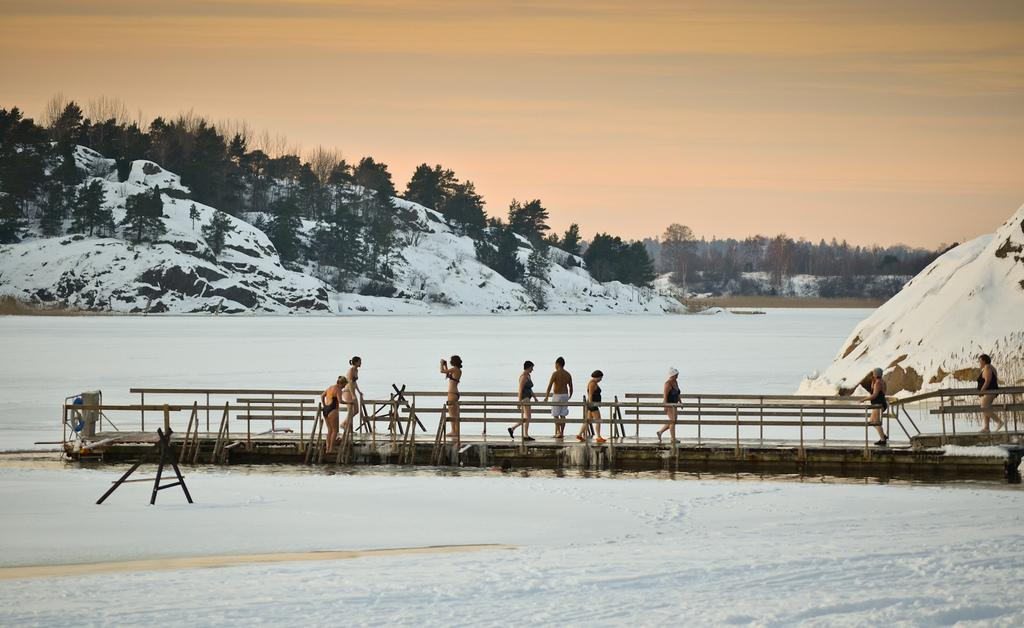How many people are in the image? There are persons in the image, but the exact number is not specified. What are the persons wearing? The persons are wearing clothes. Where are the persons standing? The persons are standing on a dock. What is in the middle of the image? There is a hill in the middle of the image. What is visible at the top of the image? There is a sky visible at the top of the image. What type of string is being used to tie the vegetables on the hill in the image? There are no vegetables or string present in the image; it features persons standing on a dock with a hill in the middle and a sky visible at the top. 